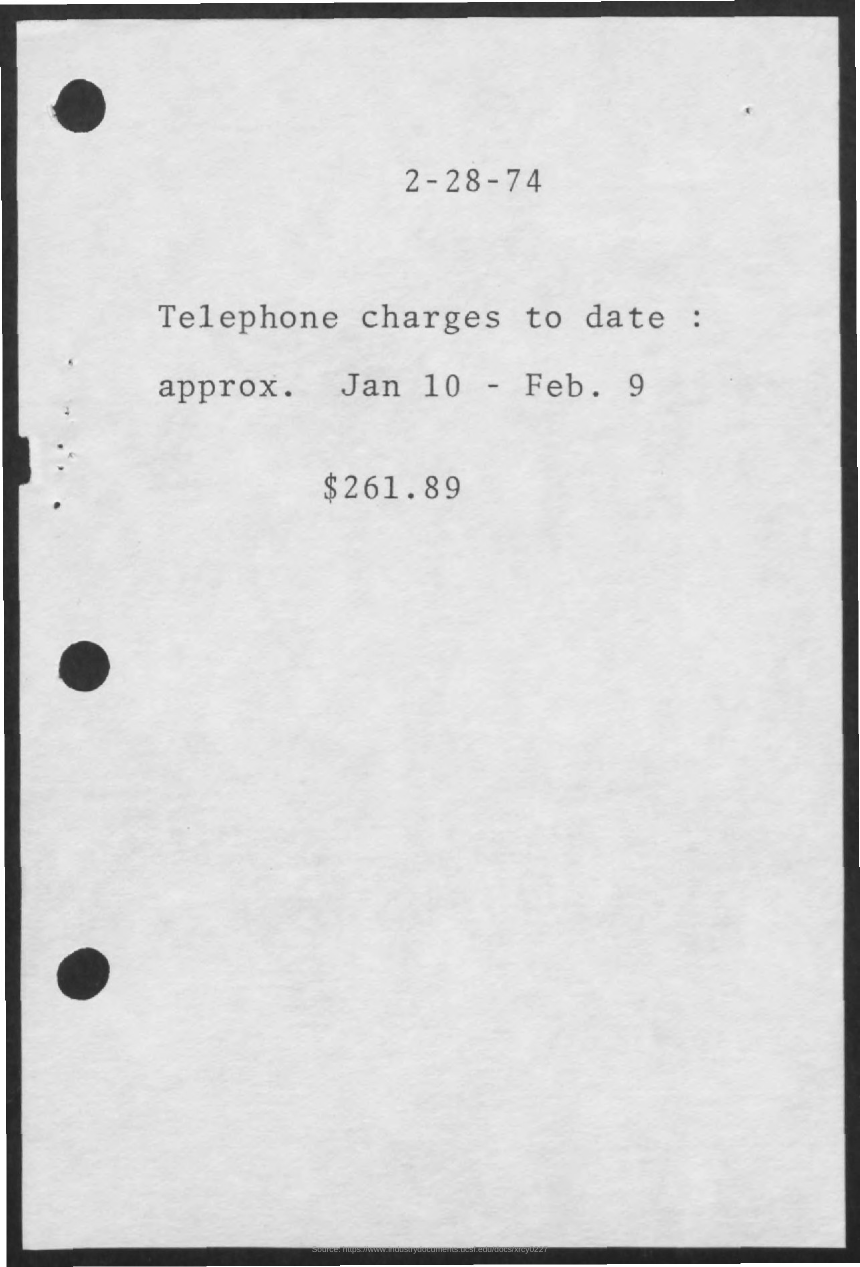Could you estimate the value of $261.89 in today's terms? While I'm not capable of giving you the exact current value, $261.89 in 1974 would be equivalent to a significantly higher amount today due to inflation. Historically, the value of currency decreases over time, meaning the purchasing power of $261.89 would be much less in the present day. 